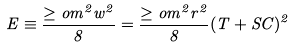<formula> <loc_0><loc_0><loc_500><loc_500>E \equiv \frac { \geq o m ^ { 2 } w ^ { 2 } } { 8 } = \frac { \geq o m ^ { 2 } r ^ { 2 } } { 8 } ( T + S C ) ^ { 2 }</formula> 